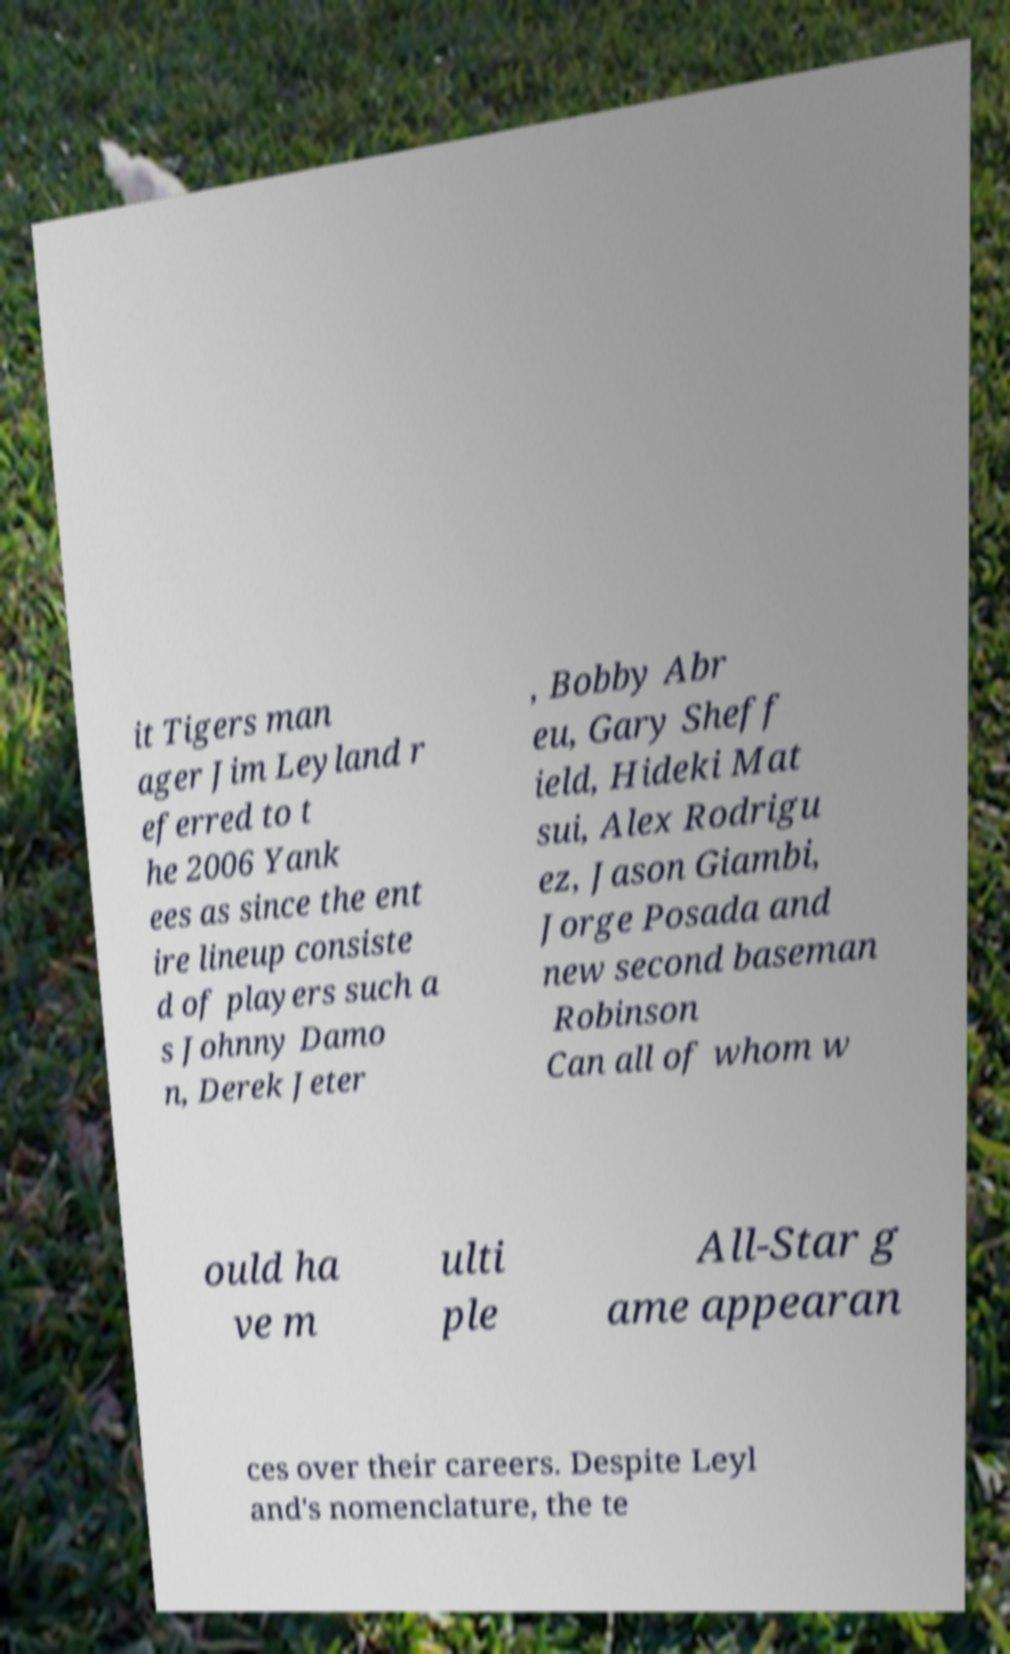Can you accurately transcribe the text from the provided image for me? it Tigers man ager Jim Leyland r eferred to t he 2006 Yank ees as since the ent ire lineup consiste d of players such a s Johnny Damo n, Derek Jeter , Bobby Abr eu, Gary Sheff ield, Hideki Mat sui, Alex Rodrigu ez, Jason Giambi, Jorge Posada and new second baseman Robinson Can all of whom w ould ha ve m ulti ple All-Star g ame appearan ces over their careers. Despite Leyl and's nomenclature, the te 